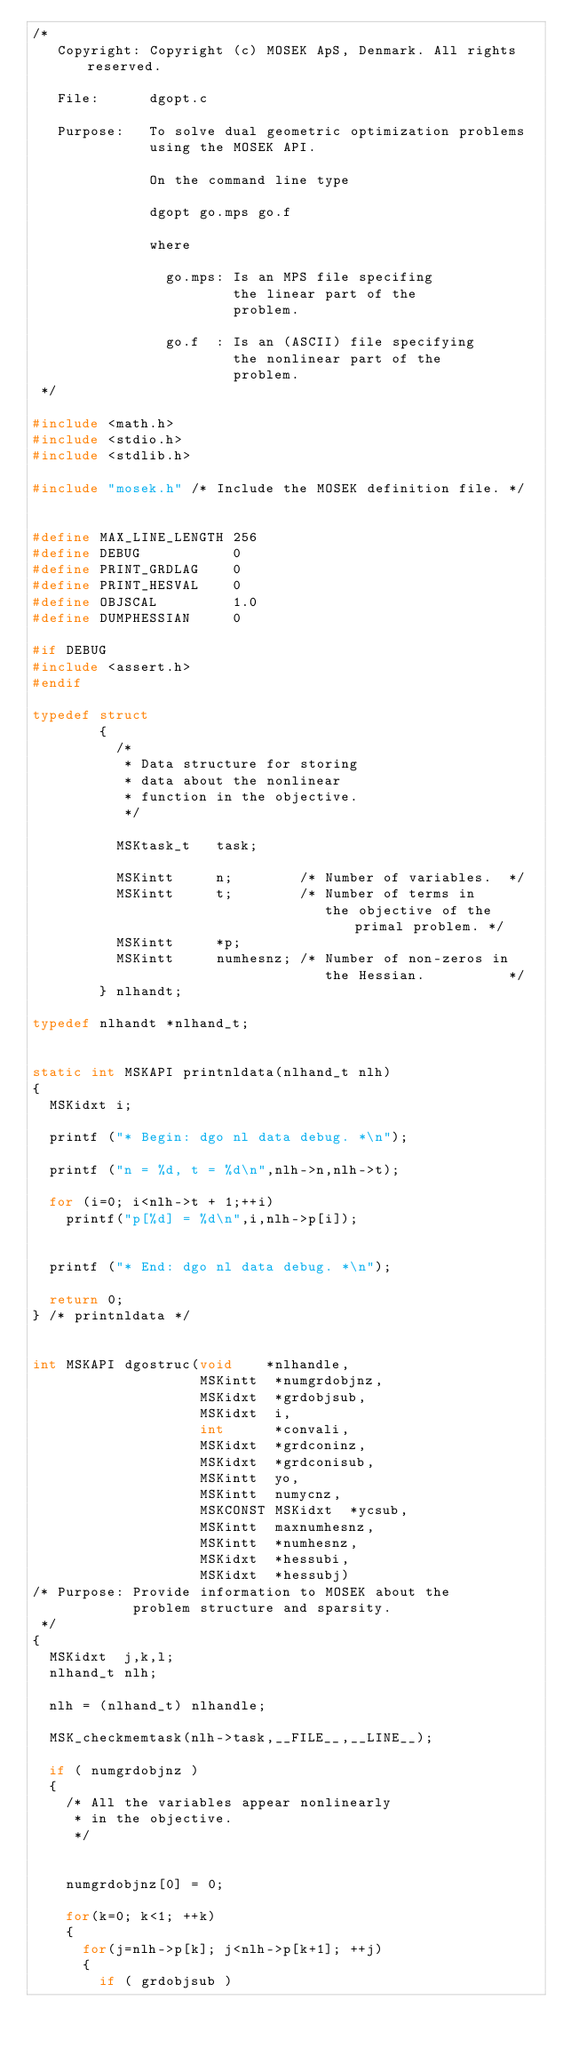<code> <loc_0><loc_0><loc_500><loc_500><_C_>/* 
   Copyright: Copyright (c) MOSEK ApS, Denmark. All rights reserved.

   File:      dgopt.c

   Purpose:   To solve dual geometric optimization problems 
              using the MOSEK API.

              On the command line type

              dgopt go.mps go.f

              where

                go.mps: Is an MPS file specifing
                        the linear part of the
                        problem.

                go.f  : Is an (ASCII) file specifying
                        the nonlinear part of the
                        problem.
 */  

#include <math.h>
#include <stdio.h>
#include <stdlib.h>

#include "mosek.h" /* Include the MOSEK definition file. */


#define MAX_LINE_LENGTH 256
#define DEBUG           0
#define PRINT_GRDLAG    0
#define PRINT_HESVAL    0
#define OBJSCAL         1.0
#define DUMPHESSIAN     0

#if DEBUG
#include <assert.h>
#endif

typedef struct
        {
          /*
           * Data structure for storing
           * data about the nonlinear
           * function in the objective.
           */

          MSKtask_t   task;

          MSKintt     n;        /* Number of variables.  */
          MSKintt     t;        /* Number of terms in
                                   the objective of the primal problem. */
          MSKintt     *p;
          MSKintt     numhesnz; /* Number of non-zeros in
                                   the Hessian.          */
        } nlhandt;

typedef nlhandt *nlhand_t;


static int MSKAPI printnldata(nlhand_t nlh)
{
  MSKidxt i;
  
  printf ("* Begin: dgo nl data debug. *\n");

  printf ("n = %d, t = %d\n",nlh->n,nlh->t);

  for (i=0; i<nlh->t + 1;++i)
    printf("p[%d] = %d\n",i,nlh->p[i]);

  
  printf ("* End: dgo nl data debug. *\n");

  return 0;
} /* printnldata */


int MSKAPI dgostruc(void    *nlhandle,
                    MSKintt  *numgrdobjnz,
                    MSKidxt  *grdobjsub,
                    MSKidxt  i,
                    int      *convali,
                    MSKidxt  *grdconinz,
                    MSKidxt  *grdconisub,
                    MSKintt  yo,
                    MSKintt  numycnz,
                    MSKCONST MSKidxt  *ycsub,
                    MSKintt  maxnumhesnz,
                    MSKintt  *numhesnz,
                    MSKidxt  *hessubi,
                    MSKidxt  *hessubj)
/* Purpose: Provide information to MOSEK about the
            problem structure and sparsity.
 */
{
  MSKidxt  j,k,l; 
  nlhand_t nlh;

  nlh = (nlhand_t) nlhandle;

  MSK_checkmemtask(nlh->task,__FILE__,__LINE__);

  if ( numgrdobjnz )
  {
    /* All the variables appear nonlinearly
     * in the objective.
     */


    numgrdobjnz[0] = 0;

    for(k=0; k<1; ++k)
    {
      for(j=nlh->p[k]; j<nlh->p[k+1]; ++j)
      {
        if ( grdobjsub )</code> 